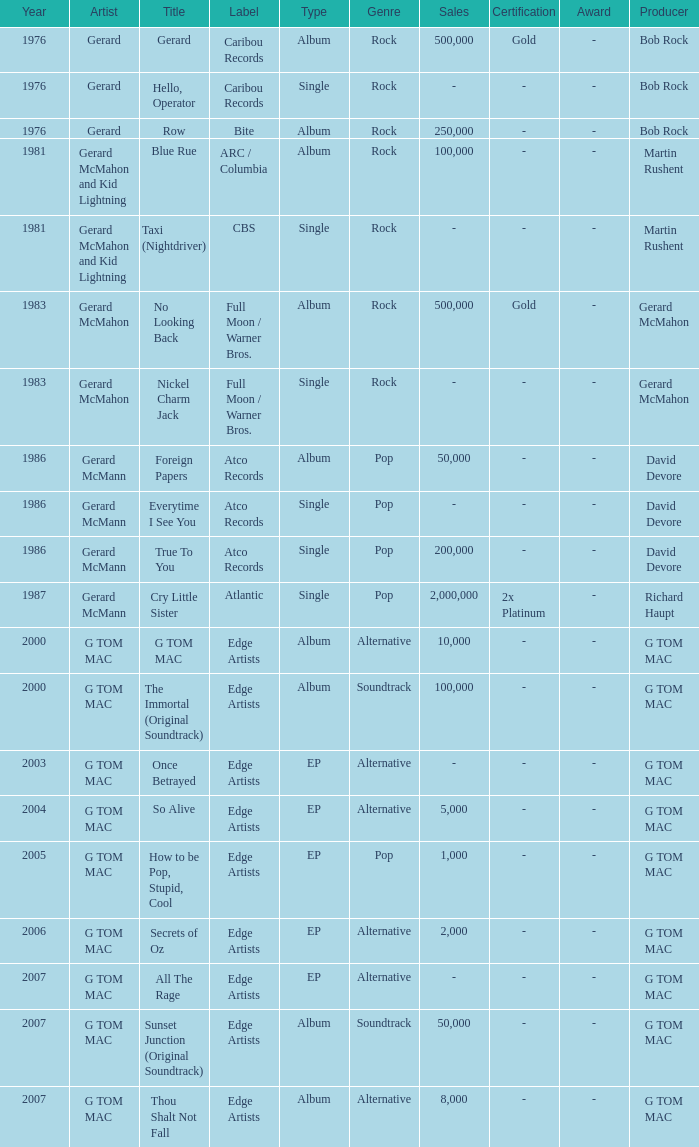Which Title has a Type of album and a Year larger than 1986? G TOM MAC, The Immortal (Original Soundtrack), Sunset Junction (Original Soundtrack), Thou Shalt Not Fall. 